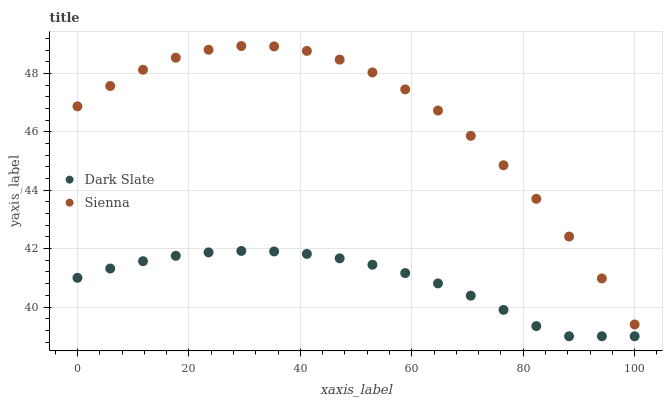Does Dark Slate have the minimum area under the curve?
Answer yes or no. Yes. Does Sienna have the maximum area under the curve?
Answer yes or no. Yes. Does Dark Slate have the maximum area under the curve?
Answer yes or no. No. Is Dark Slate the smoothest?
Answer yes or no. Yes. Is Sienna the roughest?
Answer yes or no. Yes. Is Dark Slate the roughest?
Answer yes or no. No. Does Dark Slate have the lowest value?
Answer yes or no. Yes. Does Sienna have the highest value?
Answer yes or no. Yes. Does Dark Slate have the highest value?
Answer yes or no. No. Is Dark Slate less than Sienna?
Answer yes or no. Yes. Is Sienna greater than Dark Slate?
Answer yes or no. Yes. Does Dark Slate intersect Sienna?
Answer yes or no. No. 